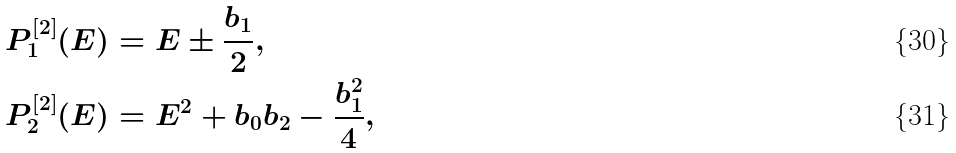Convert formula to latex. <formula><loc_0><loc_0><loc_500><loc_500>P _ { 1 } ^ { [ 2 ] } ( E ) & = E \pm \frac { b _ { 1 } } { 2 } , \\ P _ { 2 } ^ { [ 2 ] } ( E ) & = E ^ { 2 } + b _ { 0 } b _ { 2 } - \frac { b _ { 1 } ^ { 2 } } { 4 } ,</formula> 